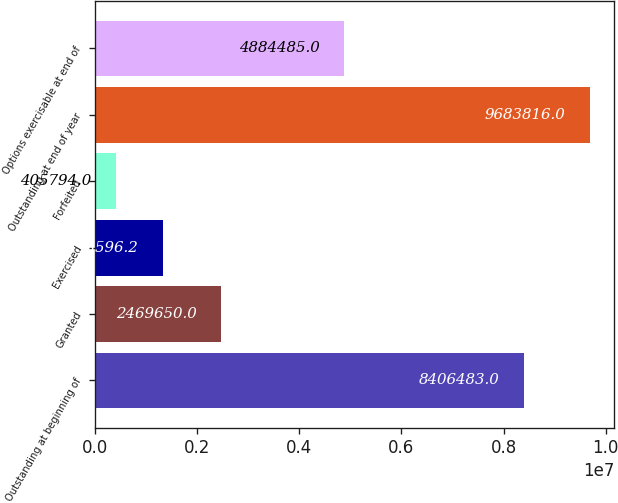Convert chart. <chart><loc_0><loc_0><loc_500><loc_500><bar_chart><fcel>Outstanding at beginning of<fcel>Granted<fcel>Exercised<fcel>Forfeited<fcel>Outstanding at end of year<fcel>Options exercisable at end of<nl><fcel>8.40648e+06<fcel>2.46965e+06<fcel>1.3336e+06<fcel>405794<fcel>9.68382e+06<fcel>4.88448e+06<nl></chart> 